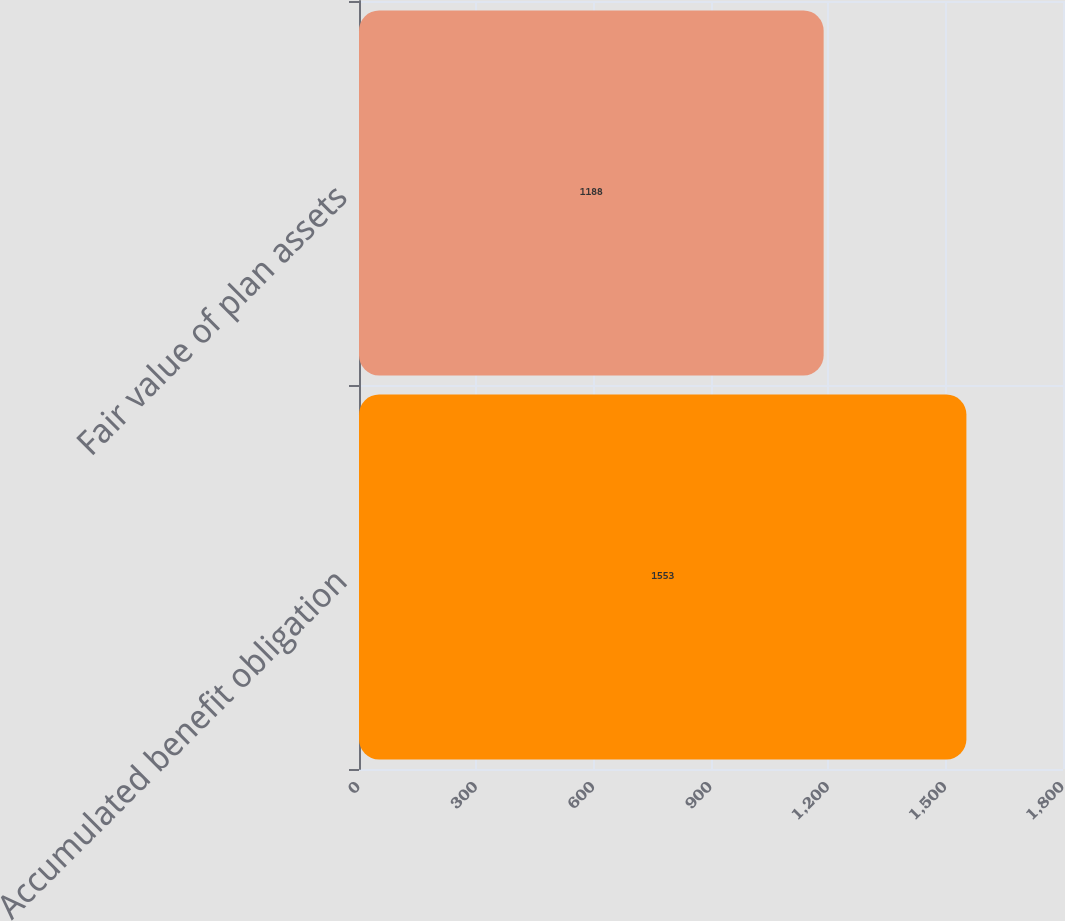Convert chart. <chart><loc_0><loc_0><loc_500><loc_500><bar_chart><fcel>Accumulated benefit obligation<fcel>Fair value of plan assets<nl><fcel>1553<fcel>1188<nl></chart> 